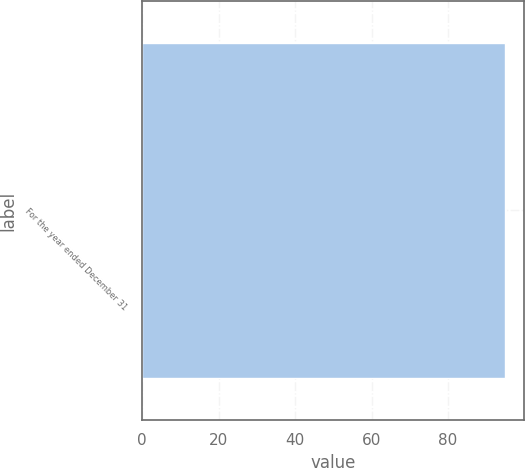Convert chart to OTSL. <chart><loc_0><loc_0><loc_500><loc_500><bar_chart><fcel>For the year ended December 31<nl><fcel>95<nl></chart> 